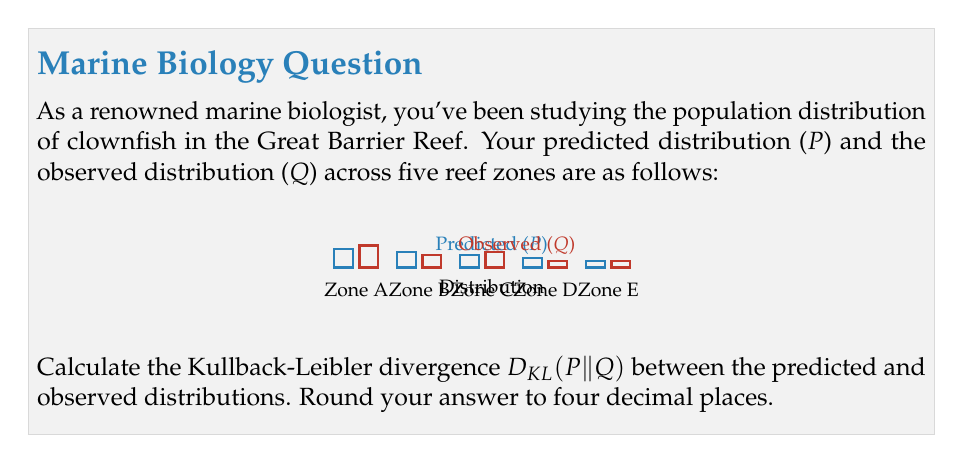What is the answer to this math problem? To solve this problem, we'll follow these steps:

1) Recall the formula for Kullback-Leibler divergence:

   $$D_{KL}(P||Q) = \sum_{i} P(i) \log\left(\frac{P(i)}{Q(i)}\right)$$

2) We have the following distributions:
   P = {0.3, 0.25, 0.2, 0.15, 0.1}
   Q = {0.35, 0.2, 0.25, 0.1, 0.1}

3) Let's calculate each term of the sum:

   For i = 1: $0.3 \log\left(\frac{0.3}{0.35}\right) = 0.3 \log(0.8571) = -0.0460$
   For i = 2: $0.25 \log\left(\frac{0.25}{0.2}\right) = 0.25 \log(1.25) = 0.0558$
   For i = 3: $0.2 \log\left(\frac{0.2}{0.25}\right) = 0.2 \log(0.8) = -0.0446$
   For i = 4: $0.15 \log\left(\frac{0.15}{0.1}\right) = 0.15 \log(1.5) = 0.0608$
   For i = 5: $0.1 \log\left(\frac{0.1}{0.1}\right) = 0.1 \log(1) = 0$

4) Sum all these terms:

   $D_{KL}(P||Q) = -0.0460 + 0.0558 - 0.0446 + 0.0608 + 0 = 0.0260$

5) Rounding to four decimal places:

   $D_{KL}(P||Q) \approx 0.0260$
Answer: 0.0260 